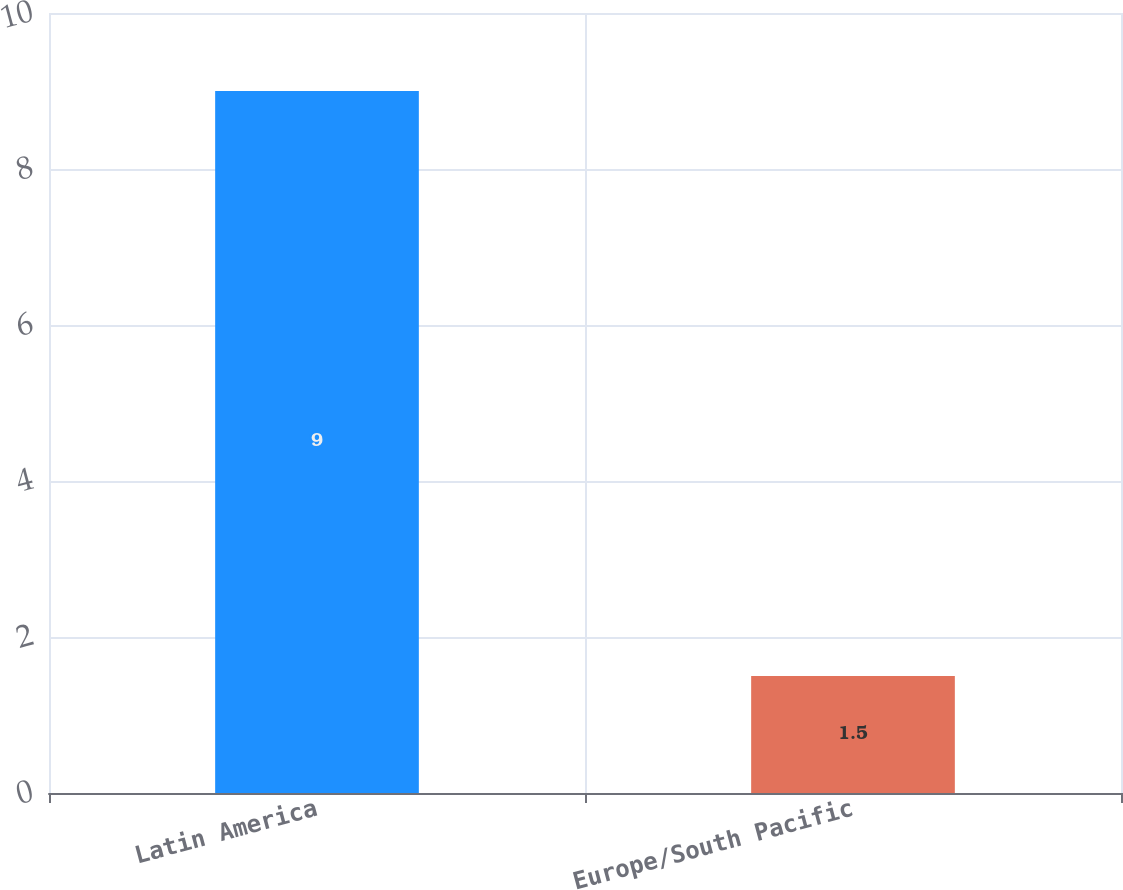<chart> <loc_0><loc_0><loc_500><loc_500><bar_chart><fcel>Latin America<fcel>Europe/South Pacific<nl><fcel>9<fcel>1.5<nl></chart> 